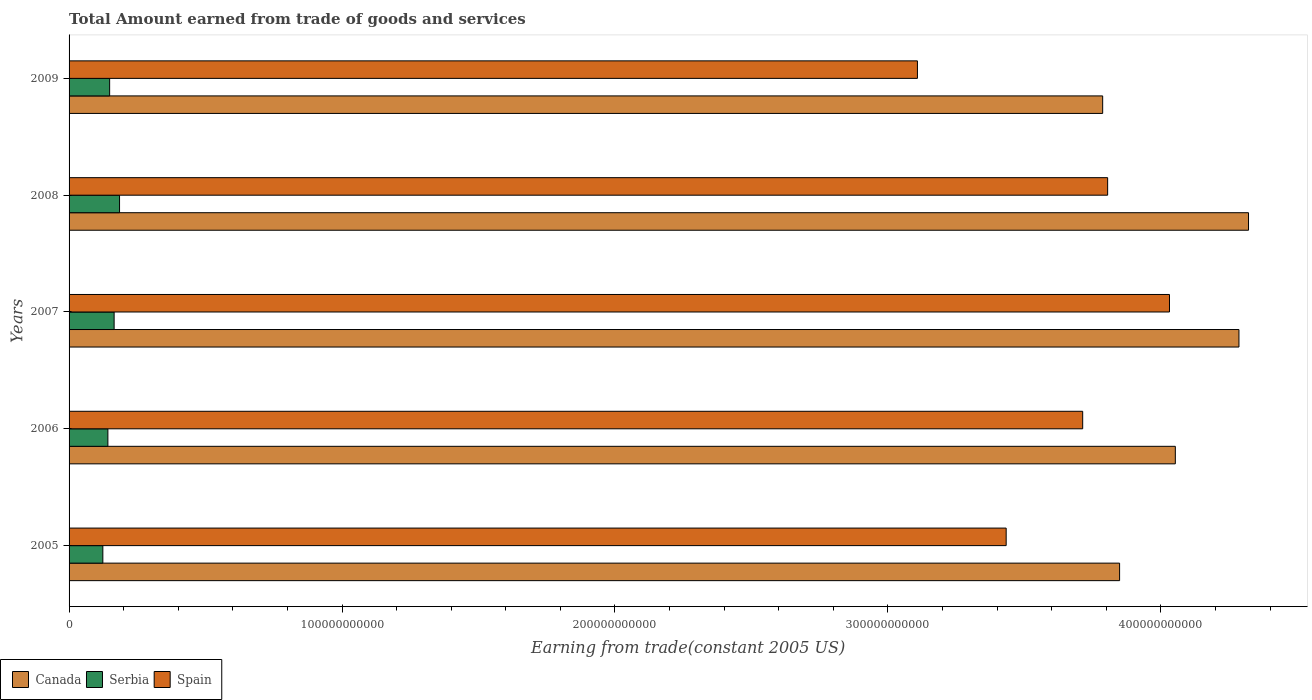How many different coloured bars are there?
Offer a very short reply. 3. How many groups of bars are there?
Keep it short and to the point. 5. Are the number of bars per tick equal to the number of legend labels?
Provide a succinct answer. Yes. Are the number of bars on each tick of the Y-axis equal?
Ensure brevity in your answer.  Yes. What is the total amount earned by trading goods and services in Serbia in 2008?
Give a very brief answer. 1.85e+1. Across all years, what is the maximum total amount earned by trading goods and services in Spain?
Make the answer very short. 4.03e+11. Across all years, what is the minimum total amount earned by trading goods and services in Spain?
Keep it short and to the point. 3.11e+11. What is the total total amount earned by trading goods and services in Serbia in the graph?
Provide a succinct answer. 7.65e+1. What is the difference between the total amount earned by trading goods and services in Serbia in 2005 and that in 2007?
Offer a terse response. -4.13e+09. What is the difference between the total amount earned by trading goods and services in Spain in 2008 and the total amount earned by trading goods and services in Serbia in 2007?
Make the answer very short. 3.64e+11. What is the average total amount earned by trading goods and services in Canada per year?
Your answer should be very brief. 4.06e+11. In the year 2006, what is the difference between the total amount earned by trading goods and services in Spain and total amount earned by trading goods and services in Canada?
Make the answer very short. -3.39e+1. In how many years, is the total amount earned by trading goods and services in Canada greater than 260000000000 US$?
Offer a very short reply. 5. What is the ratio of the total amount earned by trading goods and services in Serbia in 2005 to that in 2006?
Offer a terse response. 0.87. What is the difference between the highest and the second highest total amount earned by trading goods and services in Spain?
Keep it short and to the point. 2.27e+1. What is the difference between the highest and the lowest total amount earned by trading goods and services in Spain?
Offer a terse response. 9.23e+1. Is the sum of the total amount earned by trading goods and services in Canada in 2005 and 2006 greater than the maximum total amount earned by trading goods and services in Spain across all years?
Provide a succinct answer. Yes. What does the 1st bar from the bottom in 2007 represents?
Provide a short and direct response. Canada. How many bars are there?
Provide a short and direct response. 15. What is the difference between two consecutive major ticks on the X-axis?
Offer a very short reply. 1.00e+11. Are the values on the major ticks of X-axis written in scientific E-notation?
Keep it short and to the point. No. Does the graph contain any zero values?
Your answer should be compact. No. Does the graph contain grids?
Your answer should be very brief. No. Where does the legend appear in the graph?
Ensure brevity in your answer.  Bottom left. How many legend labels are there?
Your answer should be compact. 3. What is the title of the graph?
Ensure brevity in your answer.  Total Amount earned from trade of goods and services. Does "Guyana" appear as one of the legend labels in the graph?
Offer a terse response. No. What is the label or title of the X-axis?
Your answer should be compact. Earning from trade(constant 2005 US). What is the label or title of the Y-axis?
Your answer should be compact. Years. What is the Earning from trade(constant 2005 US) of Canada in 2005?
Ensure brevity in your answer.  3.85e+11. What is the Earning from trade(constant 2005 US) of Serbia in 2005?
Ensure brevity in your answer.  1.24e+1. What is the Earning from trade(constant 2005 US) in Spain in 2005?
Give a very brief answer. 3.43e+11. What is the Earning from trade(constant 2005 US) of Canada in 2006?
Offer a terse response. 4.05e+11. What is the Earning from trade(constant 2005 US) in Serbia in 2006?
Provide a succinct answer. 1.42e+1. What is the Earning from trade(constant 2005 US) in Spain in 2006?
Keep it short and to the point. 3.71e+11. What is the Earning from trade(constant 2005 US) in Canada in 2007?
Give a very brief answer. 4.29e+11. What is the Earning from trade(constant 2005 US) of Serbia in 2007?
Offer a very short reply. 1.65e+1. What is the Earning from trade(constant 2005 US) of Spain in 2007?
Your answer should be compact. 4.03e+11. What is the Earning from trade(constant 2005 US) in Canada in 2008?
Ensure brevity in your answer.  4.32e+11. What is the Earning from trade(constant 2005 US) of Serbia in 2008?
Offer a very short reply. 1.85e+1. What is the Earning from trade(constant 2005 US) in Spain in 2008?
Your answer should be compact. 3.81e+11. What is the Earning from trade(constant 2005 US) in Canada in 2009?
Offer a very short reply. 3.79e+11. What is the Earning from trade(constant 2005 US) in Serbia in 2009?
Your response must be concise. 1.49e+1. What is the Earning from trade(constant 2005 US) of Spain in 2009?
Make the answer very short. 3.11e+11. Across all years, what is the maximum Earning from trade(constant 2005 US) of Canada?
Keep it short and to the point. 4.32e+11. Across all years, what is the maximum Earning from trade(constant 2005 US) of Serbia?
Provide a short and direct response. 1.85e+1. Across all years, what is the maximum Earning from trade(constant 2005 US) of Spain?
Give a very brief answer. 4.03e+11. Across all years, what is the minimum Earning from trade(constant 2005 US) of Canada?
Your response must be concise. 3.79e+11. Across all years, what is the minimum Earning from trade(constant 2005 US) of Serbia?
Your answer should be compact. 1.24e+1. Across all years, what is the minimum Earning from trade(constant 2005 US) in Spain?
Provide a short and direct response. 3.11e+11. What is the total Earning from trade(constant 2005 US) of Canada in the graph?
Provide a short and direct response. 2.03e+12. What is the total Earning from trade(constant 2005 US) in Serbia in the graph?
Give a very brief answer. 7.65e+1. What is the total Earning from trade(constant 2005 US) in Spain in the graph?
Give a very brief answer. 1.81e+12. What is the difference between the Earning from trade(constant 2005 US) of Canada in 2005 and that in 2006?
Keep it short and to the point. -2.04e+1. What is the difference between the Earning from trade(constant 2005 US) in Serbia in 2005 and that in 2006?
Keep it short and to the point. -1.85e+09. What is the difference between the Earning from trade(constant 2005 US) of Spain in 2005 and that in 2006?
Your response must be concise. -2.80e+1. What is the difference between the Earning from trade(constant 2005 US) of Canada in 2005 and that in 2007?
Keep it short and to the point. -4.37e+1. What is the difference between the Earning from trade(constant 2005 US) of Serbia in 2005 and that in 2007?
Give a very brief answer. -4.13e+09. What is the difference between the Earning from trade(constant 2005 US) of Spain in 2005 and that in 2007?
Ensure brevity in your answer.  -5.98e+1. What is the difference between the Earning from trade(constant 2005 US) in Canada in 2005 and that in 2008?
Your response must be concise. -4.72e+1. What is the difference between the Earning from trade(constant 2005 US) in Serbia in 2005 and that in 2008?
Keep it short and to the point. -6.12e+09. What is the difference between the Earning from trade(constant 2005 US) in Spain in 2005 and that in 2008?
Your response must be concise. -3.72e+1. What is the difference between the Earning from trade(constant 2005 US) in Canada in 2005 and that in 2009?
Your answer should be compact. 6.20e+09. What is the difference between the Earning from trade(constant 2005 US) in Serbia in 2005 and that in 2009?
Make the answer very short. -2.49e+09. What is the difference between the Earning from trade(constant 2005 US) in Spain in 2005 and that in 2009?
Keep it short and to the point. 3.25e+1. What is the difference between the Earning from trade(constant 2005 US) in Canada in 2006 and that in 2007?
Provide a short and direct response. -2.33e+1. What is the difference between the Earning from trade(constant 2005 US) of Serbia in 2006 and that in 2007?
Provide a succinct answer. -2.29e+09. What is the difference between the Earning from trade(constant 2005 US) of Spain in 2006 and that in 2007?
Keep it short and to the point. -3.18e+1. What is the difference between the Earning from trade(constant 2005 US) in Canada in 2006 and that in 2008?
Give a very brief answer. -2.68e+1. What is the difference between the Earning from trade(constant 2005 US) of Serbia in 2006 and that in 2008?
Provide a succinct answer. -4.27e+09. What is the difference between the Earning from trade(constant 2005 US) in Spain in 2006 and that in 2008?
Your answer should be very brief. -9.15e+09. What is the difference between the Earning from trade(constant 2005 US) of Canada in 2006 and that in 2009?
Offer a very short reply. 2.66e+1. What is the difference between the Earning from trade(constant 2005 US) in Serbia in 2006 and that in 2009?
Ensure brevity in your answer.  -6.40e+08. What is the difference between the Earning from trade(constant 2005 US) in Spain in 2006 and that in 2009?
Your answer should be very brief. 6.05e+1. What is the difference between the Earning from trade(constant 2005 US) of Canada in 2007 and that in 2008?
Your answer should be very brief. -3.50e+09. What is the difference between the Earning from trade(constant 2005 US) in Serbia in 2007 and that in 2008?
Provide a succinct answer. -1.98e+09. What is the difference between the Earning from trade(constant 2005 US) in Spain in 2007 and that in 2008?
Provide a short and direct response. 2.27e+1. What is the difference between the Earning from trade(constant 2005 US) of Canada in 2007 and that in 2009?
Offer a terse response. 4.99e+1. What is the difference between the Earning from trade(constant 2005 US) of Serbia in 2007 and that in 2009?
Make the answer very short. 1.65e+09. What is the difference between the Earning from trade(constant 2005 US) in Spain in 2007 and that in 2009?
Your response must be concise. 9.23e+1. What is the difference between the Earning from trade(constant 2005 US) in Canada in 2008 and that in 2009?
Your answer should be compact. 5.34e+1. What is the difference between the Earning from trade(constant 2005 US) in Serbia in 2008 and that in 2009?
Provide a short and direct response. 3.63e+09. What is the difference between the Earning from trade(constant 2005 US) of Spain in 2008 and that in 2009?
Your answer should be very brief. 6.97e+1. What is the difference between the Earning from trade(constant 2005 US) of Canada in 2005 and the Earning from trade(constant 2005 US) of Serbia in 2006?
Ensure brevity in your answer.  3.71e+11. What is the difference between the Earning from trade(constant 2005 US) in Canada in 2005 and the Earning from trade(constant 2005 US) in Spain in 2006?
Your response must be concise. 1.35e+1. What is the difference between the Earning from trade(constant 2005 US) in Serbia in 2005 and the Earning from trade(constant 2005 US) in Spain in 2006?
Make the answer very short. -3.59e+11. What is the difference between the Earning from trade(constant 2005 US) of Canada in 2005 and the Earning from trade(constant 2005 US) of Serbia in 2007?
Your response must be concise. 3.68e+11. What is the difference between the Earning from trade(constant 2005 US) of Canada in 2005 and the Earning from trade(constant 2005 US) of Spain in 2007?
Your answer should be very brief. -1.83e+1. What is the difference between the Earning from trade(constant 2005 US) of Serbia in 2005 and the Earning from trade(constant 2005 US) of Spain in 2007?
Give a very brief answer. -3.91e+11. What is the difference between the Earning from trade(constant 2005 US) in Canada in 2005 and the Earning from trade(constant 2005 US) in Serbia in 2008?
Your response must be concise. 3.66e+11. What is the difference between the Earning from trade(constant 2005 US) in Canada in 2005 and the Earning from trade(constant 2005 US) in Spain in 2008?
Your answer should be compact. 4.38e+09. What is the difference between the Earning from trade(constant 2005 US) of Serbia in 2005 and the Earning from trade(constant 2005 US) of Spain in 2008?
Offer a terse response. -3.68e+11. What is the difference between the Earning from trade(constant 2005 US) of Canada in 2005 and the Earning from trade(constant 2005 US) of Serbia in 2009?
Provide a short and direct response. 3.70e+11. What is the difference between the Earning from trade(constant 2005 US) in Canada in 2005 and the Earning from trade(constant 2005 US) in Spain in 2009?
Your response must be concise. 7.41e+1. What is the difference between the Earning from trade(constant 2005 US) of Serbia in 2005 and the Earning from trade(constant 2005 US) of Spain in 2009?
Your answer should be compact. -2.98e+11. What is the difference between the Earning from trade(constant 2005 US) of Canada in 2006 and the Earning from trade(constant 2005 US) of Serbia in 2007?
Give a very brief answer. 3.89e+11. What is the difference between the Earning from trade(constant 2005 US) of Canada in 2006 and the Earning from trade(constant 2005 US) of Spain in 2007?
Make the answer very short. 2.14e+09. What is the difference between the Earning from trade(constant 2005 US) in Serbia in 2006 and the Earning from trade(constant 2005 US) in Spain in 2007?
Offer a very short reply. -3.89e+11. What is the difference between the Earning from trade(constant 2005 US) in Canada in 2006 and the Earning from trade(constant 2005 US) in Serbia in 2008?
Make the answer very short. 3.87e+11. What is the difference between the Earning from trade(constant 2005 US) of Canada in 2006 and the Earning from trade(constant 2005 US) of Spain in 2008?
Provide a succinct answer. 2.48e+1. What is the difference between the Earning from trade(constant 2005 US) of Serbia in 2006 and the Earning from trade(constant 2005 US) of Spain in 2008?
Provide a short and direct response. -3.66e+11. What is the difference between the Earning from trade(constant 2005 US) in Canada in 2006 and the Earning from trade(constant 2005 US) in Serbia in 2009?
Provide a succinct answer. 3.90e+11. What is the difference between the Earning from trade(constant 2005 US) in Canada in 2006 and the Earning from trade(constant 2005 US) in Spain in 2009?
Your response must be concise. 9.45e+1. What is the difference between the Earning from trade(constant 2005 US) of Serbia in 2006 and the Earning from trade(constant 2005 US) of Spain in 2009?
Offer a terse response. -2.97e+11. What is the difference between the Earning from trade(constant 2005 US) of Canada in 2007 and the Earning from trade(constant 2005 US) of Serbia in 2008?
Offer a terse response. 4.10e+11. What is the difference between the Earning from trade(constant 2005 US) of Canada in 2007 and the Earning from trade(constant 2005 US) of Spain in 2008?
Offer a terse response. 4.81e+1. What is the difference between the Earning from trade(constant 2005 US) in Serbia in 2007 and the Earning from trade(constant 2005 US) in Spain in 2008?
Your answer should be very brief. -3.64e+11. What is the difference between the Earning from trade(constant 2005 US) of Canada in 2007 and the Earning from trade(constant 2005 US) of Serbia in 2009?
Your answer should be very brief. 4.14e+11. What is the difference between the Earning from trade(constant 2005 US) in Canada in 2007 and the Earning from trade(constant 2005 US) in Spain in 2009?
Keep it short and to the point. 1.18e+11. What is the difference between the Earning from trade(constant 2005 US) in Serbia in 2007 and the Earning from trade(constant 2005 US) in Spain in 2009?
Your answer should be very brief. -2.94e+11. What is the difference between the Earning from trade(constant 2005 US) of Canada in 2008 and the Earning from trade(constant 2005 US) of Serbia in 2009?
Offer a terse response. 4.17e+11. What is the difference between the Earning from trade(constant 2005 US) of Canada in 2008 and the Earning from trade(constant 2005 US) of Spain in 2009?
Your response must be concise. 1.21e+11. What is the difference between the Earning from trade(constant 2005 US) of Serbia in 2008 and the Earning from trade(constant 2005 US) of Spain in 2009?
Your answer should be compact. -2.92e+11. What is the average Earning from trade(constant 2005 US) in Canada per year?
Your response must be concise. 4.06e+11. What is the average Earning from trade(constant 2005 US) in Serbia per year?
Your response must be concise. 1.53e+1. What is the average Earning from trade(constant 2005 US) of Spain per year?
Give a very brief answer. 3.62e+11. In the year 2005, what is the difference between the Earning from trade(constant 2005 US) of Canada and Earning from trade(constant 2005 US) of Serbia?
Offer a terse response. 3.73e+11. In the year 2005, what is the difference between the Earning from trade(constant 2005 US) of Canada and Earning from trade(constant 2005 US) of Spain?
Your response must be concise. 4.16e+1. In the year 2005, what is the difference between the Earning from trade(constant 2005 US) of Serbia and Earning from trade(constant 2005 US) of Spain?
Keep it short and to the point. -3.31e+11. In the year 2006, what is the difference between the Earning from trade(constant 2005 US) in Canada and Earning from trade(constant 2005 US) in Serbia?
Keep it short and to the point. 3.91e+11. In the year 2006, what is the difference between the Earning from trade(constant 2005 US) of Canada and Earning from trade(constant 2005 US) of Spain?
Your answer should be very brief. 3.39e+1. In the year 2006, what is the difference between the Earning from trade(constant 2005 US) in Serbia and Earning from trade(constant 2005 US) in Spain?
Your answer should be very brief. -3.57e+11. In the year 2007, what is the difference between the Earning from trade(constant 2005 US) in Canada and Earning from trade(constant 2005 US) in Serbia?
Provide a short and direct response. 4.12e+11. In the year 2007, what is the difference between the Earning from trade(constant 2005 US) in Canada and Earning from trade(constant 2005 US) in Spain?
Your answer should be compact. 2.55e+1. In the year 2007, what is the difference between the Earning from trade(constant 2005 US) in Serbia and Earning from trade(constant 2005 US) in Spain?
Your answer should be very brief. -3.87e+11. In the year 2008, what is the difference between the Earning from trade(constant 2005 US) of Canada and Earning from trade(constant 2005 US) of Serbia?
Your answer should be very brief. 4.14e+11. In the year 2008, what is the difference between the Earning from trade(constant 2005 US) of Canada and Earning from trade(constant 2005 US) of Spain?
Offer a very short reply. 5.16e+1. In the year 2008, what is the difference between the Earning from trade(constant 2005 US) of Serbia and Earning from trade(constant 2005 US) of Spain?
Offer a terse response. -3.62e+11. In the year 2009, what is the difference between the Earning from trade(constant 2005 US) in Canada and Earning from trade(constant 2005 US) in Serbia?
Offer a terse response. 3.64e+11. In the year 2009, what is the difference between the Earning from trade(constant 2005 US) in Canada and Earning from trade(constant 2005 US) in Spain?
Your answer should be very brief. 6.79e+1. In the year 2009, what is the difference between the Earning from trade(constant 2005 US) in Serbia and Earning from trade(constant 2005 US) in Spain?
Offer a terse response. -2.96e+11. What is the ratio of the Earning from trade(constant 2005 US) in Canada in 2005 to that in 2006?
Give a very brief answer. 0.95. What is the ratio of the Earning from trade(constant 2005 US) of Serbia in 2005 to that in 2006?
Your answer should be compact. 0.87. What is the ratio of the Earning from trade(constant 2005 US) of Spain in 2005 to that in 2006?
Your response must be concise. 0.92. What is the ratio of the Earning from trade(constant 2005 US) in Canada in 2005 to that in 2007?
Keep it short and to the point. 0.9. What is the ratio of the Earning from trade(constant 2005 US) of Serbia in 2005 to that in 2007?
Your answer should be very brief. 0.75. What is the ratio of the Earning from trade(constant 2005 US) of Spain in 2005 to that in 2007?
Ensure brevity in your answer.  0.85. What is the ratio of the Earning from trade(constant 2005 US) in Canada in 2005 to that in 2008?
Offer a terse response. 0.89. What is the ratio of the Earning from trade(constant 2005 US) in Serbia in 2005 to that in 2008?
Ensure brevity in your answer.  0.67. What is the ratio of the Earning from trade(constant 2005 US) of Spain in 2005 to that in 2008?
Your response must be concise. 0.9. What is the ratio of the Earning from trade(constant 2005 US) in Canada in 2005 to that in 2009?
Your answer should be compact. 1.02. What is the ratio of the Earning from trade(constant 2005 US) of Serbia in 2005 to that in 2009?
Make the answer very short. 0.83. What is the ratio of the Earning from trade(constant 2005 US) in Spain in 2005 to that in 2009?
Make the answer very short. 1.1. What is the ratio of the Earning from trade(constant 2005 US) in Canada in 2006 to that in 2007?
Make the answer very short. 0.95. What is the ratio of the Earning from trade(constant 2005 US) in Serbia in 2006 to that in 2007?
Offer a terse response. 0.86. What is the ratio of the Earning from trade(constant 2005 US) of Spain in 2006 to that in 2007?
Your answer should be very brief. 0.92. What is the ratio of the Earning from trade(constant 2005 US) of Canada in 2006 to that in 2008?
Ensure brevity in your answer.  0.94. What is the ratio of the Earning from trade(constant 2005 US) in Serbia in 2006 to that in 2008?
Your answer should be very brief. 0.77. What is the ratio of the Earning from trade(constant 2005 US) of Spain in 2006 to that in 2008?
Your answer should be very brief. 0.98. What is the ratio of the Earning from trade(constant 2005 US) in Canada in 2006 to that in 2009?
Your answer should be very brief. 1.07. What is the ratio of the Earning from trade(constant 2005 US) in Serbia in 2006 to that in 2009?
Offer a very short reply. 0.96. What is the ratio of the Earning from trade(constant 2005 US) of Spain in 2006 to that in 2009?
Your response must be concise. 1.19. What is the ratio of the Earning from trade(constant 2005 US) of Canada in 2007 to that in 2008?
Make the answer very short. 0.99. What is the ratio of the Earning from trade(constant 2005 US) of Serbia in 2007 to that in 2008?
Provide a short and direct response. 0.89. What is the ratio of the Earning from trade(constant 2005 US) of Spain in 2007 to that in 2008?
Provide a short and direct response. 1.06. What is the ratio of the Earning from trade(constant 2005 US) in Canada in 2007 to that in 2009?
Provide a short and direct response. 1.13. What is the ratio of the Earning from trade(constant 2005 US) of Serbia in 2007 to that in 2009?
Make the answer very short. 1.11. What is the ratio of the Earning from trade(constant 2005 US) of Spain in 2007 to that in 2009?
Provide a short and direct response. 1.3. What is the ratio of the Earning from trade(constant 2005 US) in Canada in 2008 to that in 2009?
Offer a very short reply. 1.14. What is the ratio of the Earning from trade(constant 2005 US) of Serbia in 2008 to that in 2009?
Ensure brevity in your answer.  1.24. What is the ratio of the Earning from trade(constant 2005 US) in Spain in 2008 to that in 2009?
Offer a terse response. 1.22. What is the difference between the highest and the second highest Earning from trade(constant 2005 US) of Canada?
Your answer should be compact. 3.50e+09. What is the difference between the highest and the second highest Earning from trade(constant 2005 US) in Serbia?
Provide a short and direct response. 1.98e+09. What is the difference between the highest and the second highest Earning from trade(constant 2005 US) of Spain?
Provide a short and direct response. 2.27e+1. What is the difference between the highest and the lowest Earning from trade(constant 2005 US) in Canada?
Make the answer very short. 5.34e+1. What is the difference between the highest and the lowest Earning from trade(constant 2005 US) of Serbia?
Your response must be concise. 6.12e+09. What is the difference between the highest and the lowest Earning from trade(constant 2005 US) of Spain?
Your answer should be compact. 9.23e+1. 